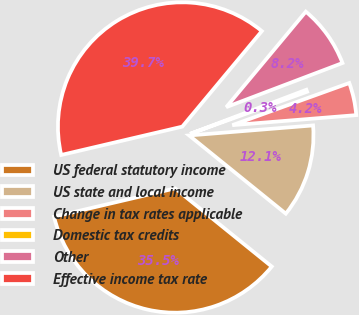Convert chart to OTSL. <chart><loc_0><loc_0><loc_500><loc_500><pie_chart><fcel>US federal statutory income<fcel>US state and local income<fcel>Change in tax rates applicable<fcel>Domestic tax credits<fcel>Other<fcel>Effective income tax rate<nl><fcel>35.51%<fcel>12.11%<fcel>4.22%<fcel>0.27%<fcel>8.17%<fcel>39.71%<nl></chart> 